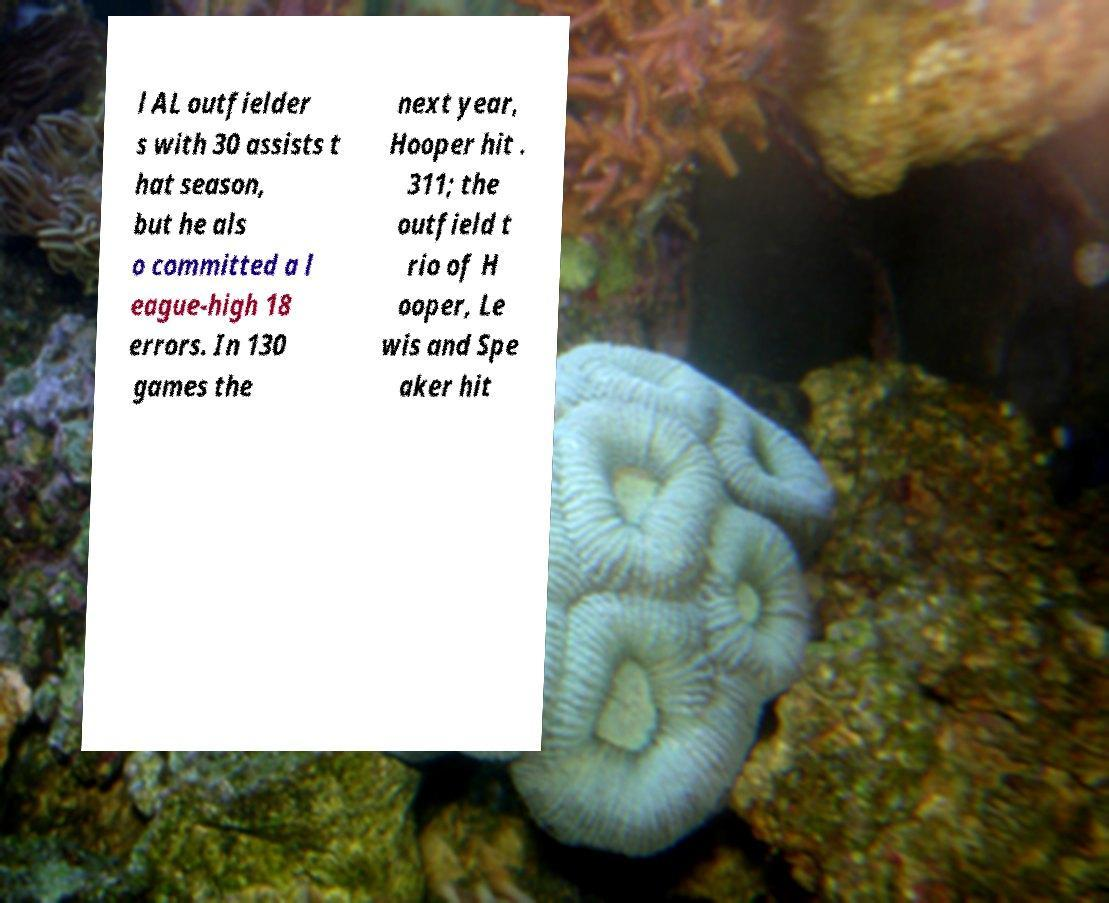I need the written content from this picture converted into text. Can you do that? l AL outfielder s with 30 assists t hat season, but he als o committed a l eague-high 18 errors. In 130 games the next year, Hooper hit . 311; the outfield t rio of H ooper, Le wis and Spe aker hit 